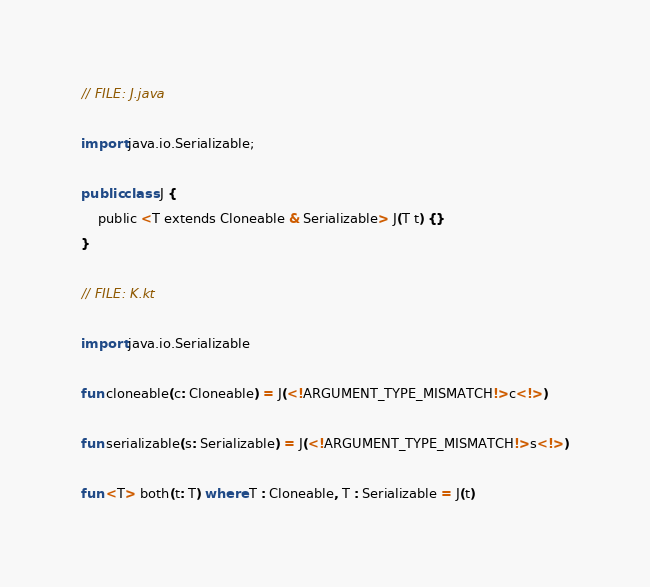Convert code to text. <code><loc_0><loc_0><loc_500><loc_500><_Kotlin_>// FILE: J.java

import java.io.Serializable;

public class J {
    public <T extends Cloneable & Serializable> J(T t) {}
}

// FILE: K.kt

import java.io.Serializable

fun cloneable(c: Cloneable) = J(<!ARGUMENT_TYPE_MISMATCH!>c<!>)

fun serializable(s: Serializable) = J(<!ARGUMENT_TYPE_MISMATCH!>s<!>)

fun <T> both(t: T) where T : Cloneable, T : Serializable = J(t)
</code> 